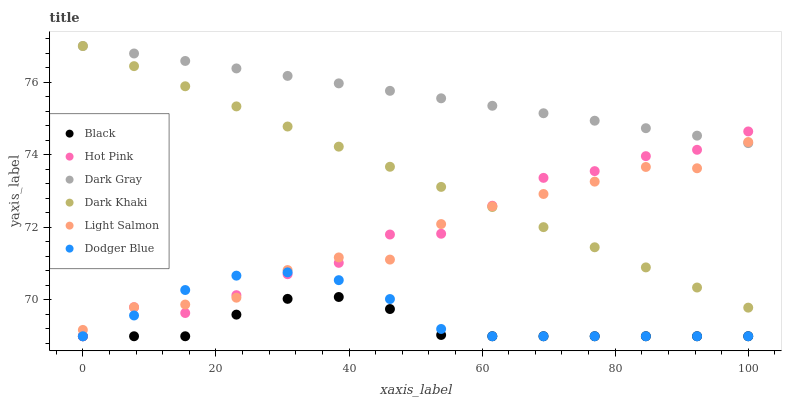Does Black have the minimum area under the curve?
Answer yes or no. Yes. Does Dark Gray have the maximum area under the curve?
Answer yes or no. Yes. Does Light Salmon have the minimum area under the curve?
Answer yes or no. No. Does Light Salmon have the maximum area under the curve?
Answer yes or no. No. Is Dark Gray the smoothest?
Answer yes or no. Yes. Is Hot Pink the roughest?
Answer yes or no. Yes. Is Light Salmon the smoothest?
Answer yes or no. No. Is Light Salmon the roughest?
Answer yes or no. No. Does Hot Pink have the lowest value?
Answer yes or no. Yes. Does Light Salmon have the lowest value?
Answer yes or no. No. Does Dark Gray have the highest value?
Answer yes or no. Yes. Does Light Salmon have the highest value?
Answer yes or no. No. Is Black less than Dark Gray?
Answer yes or no. Yes. Is Dark Gray greater than Black?
Answer yes or no. Yes. Does Dark Gray intersect Dark Khaki?
Answer yes or no. Yes. Is Dark Gray less than Dark Khaki?
Answer yes or no. No. Is Dark Gray greater than Dark Khaki?
Answer yes or no. No. Does Black intersect Dark Gray?
Answer yes or no. No. 